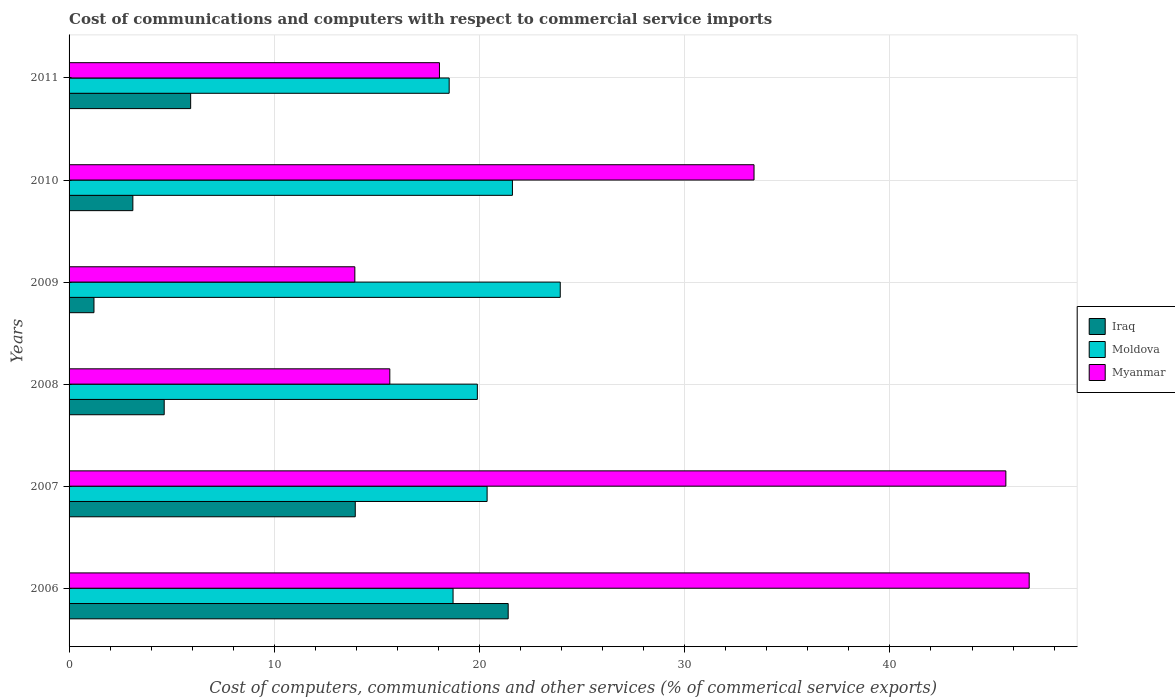Are the number of bars per tick equal to the number of legend labels?
Ensure brevity in your answer.  Yes. Are the number of bars on each tick of the Y-axis equal?
Make the answer very short. Yes. What is the label of the 2nd group of bars from the top?
Offer a very short reply. 2010. What is the cost of communications and computers in Moldova in 2008?
Ensure brevity in your answer.  19.9. Across all years, what is the maximum cost of communications and computers in Moldova?
Ensure brevity in your answer.  23.94. Across all years, what is the minimum cost of communications and computers in Iraq?
Ensure brevity in your answer.  1.21. In which year was the cost of communications and computers in Myanmar maximum?
Your answer should be compact. 2006. What is the total cost of communications and computers in Iraq in the graph?
Give a very brief answer. 50.23. What is the difference between the cost of communications and computers in Moldova in 2006 and that in 2009?
Keep it short and to the point. -5.22. What is the difference between the cost of communications and computers in Iraq in 2010 and the cost of communications and computers in Moldova in 2008?
Provide a succinct answer. -16.79. What is the average cost of communications and computers in Iraq per year?
Make the answer very short. 8.37. In the year 2007, what is the difference between the cost of communications and computers in Myanmar and cost of communications and computers in Moldova?
Ensure brevity in your answer.  25.28. In how many years, is the cost of communications and computers in Iraq greater than 14 %?
Offer a terse response. 1. What is the ratio of the cost of communications and computers in Myanmar in 2010 to that in 2011?
Ensure brevity in your answer.  1.85. Is the difference between the cost of communications and computers in Myanmar in 2010 and 2011 greater than the difference between the cost of communications and computers in Moldova in 2010 and 2011?
Provide a succinct answer. Yes. What is the difference between the highest and the second highest cost of communications and computers in Myanmar?
Your answer should be compact. 1.14. What is the difference between the highest and the lowest cost of communications and computers in Iraq?
Provide a short and direct response. 20.19. What does the 2nd bar from the top in 2010 represents?
Provide a short and direct response. Moldova. What does the 3rd bar from the bottom in 2010 represents?
Your answer should be compact. Myanmar. How many bars are there?
Make the answer very short. 18. Are all the bars in the graph horizontal?
Provide a succinct answer. Yes. How many years are there in the graph?
Provide a succinct answer. 6. What is the difference between two consecutive major ticks on the X-axis?
Your response must be concise. 10. Are the values on the major ticks of X-axis written in scientific E-notation?
Your response must be concise. No. Does the graph contain grids?
Give a very brief answer. Yes. How many legend labels are there?
Provide a succinct answer. 3. What is the title of the graph?
Your answer should be compact. Cost of communications and computers with respect to commercial service imports. What is the label or title of the X-axis?
Provide a short and direct response. Cost of computers, communications and other services (% of commerical service exports). What is the Cost of computers, communications and other services (% of commerical service exports) in Iraq in 2006?
Provide a short and direct response. 21.4. What is the Cost of computers, communications and other services (% of commerical service exports) of Moldova in 2006?
Make the answer very short. 18.71. What is the Cost of computers, communications and other services (% of commerical service exports) in Myanmar in 2006?
Provide a succinct answer. 46.79. What is the Cost of computers, communications and other services (% of commerical service exports) of Iraq in 2007?
Provide a short and direct response. 13.95. What is the Cost of computers, communications and other services (% of commerical service exports) in Moldova in 2007?
Provide a short and direct response. 20.37. What is the Cost of computers, communications and other services (% of commerical service exports) in Myanmar in 2007?
Give a very brief answer. 45.65. What is the Cost of computers, communications and other services (% of commerical service exports) in Iraq in 2008?
Offer a terse response. 4.64. What is the Cost of computers, communications and other services (% of commerical service exports) in Moldova in 2008?
Keep it short and to the point. 19.9. What is the Cost of computers, communications and other services (% of commerical service exports) of Myanmar in 2008?
Provide a succinct answer. 15.63. What is the Cost of computers, communications and other services (% of commerical service exports) of Iraq in 2009?
Ensure brevity in your answer.  1.21. What is the Cost of computers, communications and other services (% of commerical service exports) of Moldova in 2009?
Your response must be concise. 23.94. What is the Cost of computers, communications and other services (% of commerical service exports) in Myanmar in 2009?
Keep it short and to the point. 13.93. What is the Cost of computers, communications and other services (% of commerical service exports) of Iraq in 2010?
Ensure brevity in your answer.  3.11. What is the Cost of computers, communications and other services (% of commerical service exports) of Moldova in 2010?
Provide a succinct answer. 21.6. What is the Cost of computers, communications and other services (% of commerical service exports) in Myanmar in 2010?
Offer a very short reply. 33.38. What is the Cost of computers, communications and other services (% of commerical service exports) in Iraq in 2011?
Your response must be concise. 5.92. What is the Cost of computers, communications and other services (% of commerical service exports) in Moldova in 2011?
Give a very brief answer. 18.52. What is the Cost of computers, communications and other services (% of commerical service exports) in Myanmar in 2011?
Make the answer very short. 18.05. Across all years, what is the maximum Cost of computers, communications and other services (% of commerical service exports) in Iraq?
Your response must be concise. 21.4. Across all years, what is the maximum Cost of computers, communications and other services (% of commerical service exports) in Moldova?
Your answer should be very brief. 23.94. Across all years, what is the maximum Cost of computers, communications and other services (% of commerical service exports) in Myanmar?
Your answer should be very brief. 46.79. Across all years, what is the minimum Cost of computers, communications and other services (% of commerical service exports) in Iraq?
Your answer should be compact. 1.21. Across all years, what is the minimum Cost of computers, communications and other services (% of commerical service exports) in Moldova?
Keep it short and to the point. 18.52. Across all years, what is the minimum Cost of computers, communications and other services (% of commerical service exports) of Myanmar?
Your response must be concise. 13.93. What is the total Cost of computers, communications and other services (% of commerical service exports) of Iraq in the graph?
Keep it short and to the point. 50.23. What is the total Cost of computers, communications and other services (% of commerical service exports) in Moldova in the graph?
Provide a succinct answer. 123.04. What is the total Cost of computers, communications and other services (% of commerical service exports) of Myanmar in the graph?
Make the answer very short. 173.42. What is the difference between the Cost of computers, communications and other services (% of commerical service exports) in Iraq in 2006 and that in 2007?
Ensure brevity in your answer.  7.45. What is the difference between the Cost of computers, communications and other services (% of commerical service exports) in Moldova in 2006 and that in 2007?
Offer a terse response. -1.66. What is the difference between the Cost of computers, communications and other services (% of commerical service exports) in Myanmar in 2006 and that in 2007?
Make the answer very short. 1.14. What is the difference between the Cost of computers, communications and other services (% of commerical service exports) of Iraq in 2006 and that in 2008?
Provide a short and direct response. 16.76. What is the difference between the Cost of computers, communications and other services (% of commerical service exports) of Moldova in 2006 and that in 2008?
Offer a terse response. -1.18. What is the difference between the Cost of computers, communications and other services (% of commerical service exports) of Myanmar in 2006 and that in 2008?
Your response must be concise. 31.16. What is the difference between the Cost of computers, communications and other services (% of commerical service exports) of Iraq in 2006 and that in 2009?
Offer a terse response. 20.19. What is the difference between the Cost of computers, communications and other services (% of commerical service exports) in Moldova in 2006 and that in 2009?
Make the answer very short. -5.22. What is the difference between the Cost of computers, communications and other services (% of commerical service exports) in Myanmar in 2006 and that in 2009?
Your answer should be compact. 32.86. What is the difference between the Cost of computers, communications and other services (% of commerical service exports) of Iraq in 2006 and that in 2010?
Make the answer very short. 18.29. What is the difference between the Cost of computers, communications and other services (% of commerical service exports) of Moldova in 2006 and that in 2010?
Ensure brevity in your answer.  -2.89. What is the difference between the Cost of computers, communications and other services (% of commerical service exports) in Myanmar in 2006 and that in 2010?
Keep it short and to the point. 13.41. What is the difference between the Cost of computers, communications and other services (% of commerical service exports) of Iraq in 2006 and that in 2011?
Offer a terse response. 15.47. What is the difference between the Cost of computers, communications and other services (% of commerical service exports) of Moldova in 2006 and that in 2011?
Make the answer very short. 0.19. What is the difference between the Cost of computers, communications and other services (% of commerical service exports) of Myanmar in 2006 and that in 2011?
Ensure brevity in your answer.  28.74. What is the difference between the Cost of computers, communications and other services (% of commerical service exports) in Iraq in 2007 and that in 2008?
Ensure brevity in your answer.  9.31. What is the difference between the Cost of computers, communications and other services (% of commerical service exports) of Moldova in 2007 and that in 2008?
Keep it short and to the point. 0.48. What is the difference between the Cost of computers, communications and other services (% of commerical service exports) in Myanmar in 2007 and that in 2008?
Give a very brief answer. 30.02. What is the difference between the Cost of computers, communications and other services (% of commerical service exports) of Iraq in 2007 and that in 2009?
Ensure brevity in your answer.  12.73. What is the difference between the Cost of computers, communications and other services (% of commerical service exports) of Moldova in 2007 and that in 2009?
Offer a terse response. -3.56. What is the difference between the Cost of computers, communications and other services (% of commerical service exports) of Myanmar in 2007 and that in 2009?
Offer a terse response. 31.72. What is the difference between the Cost of computers, communications and other services (% of commerical service exports) in Iraq in 2007 and that in 2010?
Your answer should be compact. 10.84. What is the difference between the Cost of computers, communications and other services (% of commerical service exports) in Moldova in 2007 and that in 2010?
Ensure brevity in your answer.  -1.23. What is the difference between the Cost of computers, communications and other services (% of commerical service exports) in Myanmar in 2007 and that in 2010?
Make the answer very short. 12.27. What is the difference between the Cost of computers, communications and other services (% of commerical service exports) in Iraq in 2007 and that in 2011?
Keep it short and to the point. 8.02. What is the difference between the Cost of computers, communications and other services (% of commerical service exports) of Moldova in 2007 and that in 2011?
Your answer should be very brief. 1.85. What is the difference between the Cost of computers, communications and other services (% of commerical service exports) of Myanmar in 2007 and that in 2011?
Your response must be concise. 27.6. What is the difference between the Cost of computers, communications and other services (% of commerical service exports) in Iraq in 2008 and that in 2009?
Your answer should be compact. 3.42. What is the difference between the Cost of computers, communications and other services (% of commerical service exports) of Moldova in 2008 and that in 2009?
Your answer should be very brief. -4.04. What is the difference between the Cost of computers, communications and other services (% of commerical service exports) of Myanmar in 2008 and that in 2009?
Offer a terse response. 1.7. What is the difference between the Cost of computers, communications and other services (% of commerical service exports) of Iraq in 2008 and that in 2010?
Provide a succinct answer. 1.53. What is the difference between the Cost of computers, communications and other services (% of commerical service exports) of Moldova in 2008 and that in 2010?
Make the answer very short. -1.71. What is the difference between the Cost of computers, communications and other services (% of commerical service exports) in Myanmar in 2008 and that in 2010?
Ensure brevity in your answer.  -17.75. What is the difference between the Cost of computers, communications and other services (% of commerical service exports) in Iraq in 2008 and that in 2011?
Your response must be concise. -1.29. What is the difference between the Cost of computers, communications and other services (% of commerical service exports) of Moldova in 2008 and that in 2011?
Give a very brief answer. 1.37. What is the difference between the Cost of computers, communications and other services (% of commerical service exports) of Myanmar in 2008 and that in 2011?
Provide a short and direct response. -2.42. What is the difference between the Cost of computers, communications and other services (% of commerical service exports) of Iraq in 2009 and that in 2010?
Keep it short and to the point. -1.9. What is the difference between the Cost of computers, communications and other services (% of commerical service exports) in Moldova in 2009 and that in 2010?
Ensure brevity in your answer.  2.33. What is the difference between the Cost of computers, communications and other services (% of commerical service exports) of Myanmar in 2009 and that in 2010?
Your answer should be very brief. -19.45. What is the difference between the Cost of computers, communications and other services (% of commerical service exports) in Iraq in 2009 and that in 2011?
Your response must be concise. -4.71. What is the difference between the Cost of computers, communications and other services (% of commerical service exports) in Moldova in 2009 and that in 2011?
Your response must be concise. 5.41. What is the difference between the Cost of computers, communications and other services (% of commerical service exports) in Myanmar in 2009 and that in 2011?
Offer a very short reply. -4.12. What is the difference between the Cost of computers, communications and other services (% of commerical service exports) in Iraq in 2010 and that in 2011?
Keep it short and to the point. -2.82. What is the difference between the Cost of computers, communications and other services (% of commerical service exports) in Moldova in 2010 and that in 2011?
Your answer should be very brief. 3.08. What is the difference between the Cost of computers, communications and other services (% of commerical service exports) in Myanmar in 2010 and that in 2011?
Ensure brevity in your answer.  15.33. What is the difference between the Cost of computers, communications and other services (% of commerical service exports) in Iraq in 2006 and the Cost of computers, communications and other services (% of commerical service exports) in Moldova in 2007?
Provide a succinct answer. 1.03. What is the difference between the Cost of computers, communications and other services (% of commerical service exports) in Iraq in 2006 and the Cost of computers, communications and other services (% of commerical service exports) in Myanmar in 2007?
Make the answer very short. -24.25. What is the difference between the Cost of computers, communications and other services (% of commerical service exports) of Moldova in 2006 and the Cost of computers, communications and other services (% of commerical service exports) of Myanmar in 2007?
Ensure brevity in your answer.  -26.94. What is the difference between the Cost of computers, communications and other services (% of commerical service exports) in Iraq in 2006 and the Cost of computers, communications and other services (% of commerical service exports) in Moldova in 2008?
Your answer should be very brief. 1.5. What is the difference between the Cost of computers, communications and other services (% of commerical service exports) in Iraq in 2006 and the Cost of computers, communications and other services (% of commerical service exports) in Myanmar in 2008?
Make the answer very short. 5.77. What is the difference between the Cost of computers, communications and other services (% of commerical service exports) in Moldova in 2006 and the Cost of computers, communications and other services (% of commerical service exports) in Myanmar in 2008?
Offer a terse response. 3.08. What is the difference between the Cost of computers, communications and other services (% of commerical service exports) in Iraq in 2006 and the Cost of computers, communications and other services (% of commerical service exports) in Moldova in 2009?
Your answer should be compact. -2.54. What is the difference between the Cost of computers, communications and other services (% of commerical service exports) in Iraq in 2006 and the Cost of computers, communications and other services (% of commerical service exports) in Myanmar in 2009?
Provide a succinct answer. 7.47. What is the difference between the Cost of computers, communications and other services (% of commerical service exports) of Moldova in 2006 and the Cost of computers, communications and other services (% of commerical service exports) of Myanmar in 2009?
Provide a succinct answer. 4.79. What is the difference between the Cost of computers, communications and other services (% of commerical service exports) of Iraq in 2006 and the Cost of computers, communications and other services (% of commerical service exports) of Moldova in 2010?
Your response must be concise. -0.21. What is the difference between the Cost of computers, communications and other services (% of commerical service exports) in Iraq in 2006 and the Cost of computers, communications and other services (% of commerical service exports) in Myanmar in 2010?
Your answer should be compact. -11.98. What is the difference between the Cost of computers, communications and other services (% of commerical service exports) in Moldova in 2006 and the Cost of computers, communications and other services (% of commerical service exports) in Myanmar in 2010?
Offer a terse response. -14.67. What is the difference between the Cost of computers, communications and other services (% of commerical service exports) of Iraq in 2006 and the Cost of computers, communications and other services (% of commerical service exports) of Moldova in 2011?
Provide a succinct answer. 2.88. What is the difference between the Cost of computers, communications and other services (% of commerical service exports) of Iraq in 2006 and the Cost of computers, communications and other services (% of commerical service exports) of Myanmar in 2011?
Provide a succinct answer. 3.35. What is the difference between the Cost of computers, communications and other services (% of commerical service exports) in Moldova in 2006 and the Cost of computers, communications and other services (% of commerical service exports) in Myanmar in 2011?
Your answer should be compact. 0.66. What is the difference between the Cost of computers, communications and other services (% of commerical service exports) of Iraq in 2007 and the Cost of computers, communications and other services (% of commerical service exports) of Moldova in 2008?
Your response must be concise. -5.95. What is the difference between the Cost of computers, communications and other services (% of commerical service exports) in Iraq in 2007 and the Cost of computers, communications and other services (% of commerical service exports) in Myanmar in 2008?
Your answer should be very brief. -1.68. What is the difference between the Cost of computers, communications and other services (% of commerical service exports) of Moldova in 2007 and the Cost of computers, communications and other services (% of commerical service exports) of Myanmar in 2008?
Your answer should be compact. 4.74. What is the difference between the Cost of computers, communications and other services (% of commerical service exports) of Iraq in 2007 and the Cost of computers, communications and other services (% of commerical service exports) of Moldova in 2009?
Ensure brevity in your answer.  -9.99. What is the difference between the Cost of computers, communications and other services (% of commerical service exports) in Iraq in 2007 and the Cost of computers, communications and other services (% of commerical service exports) in Myanmar in 2009?
Give a very brief answer. 0.02. What is the difference between the Cost of computers, communications and other services (% of commerical service exports) in Moldova in 2007 and the Cost of computers, communications and other services (% of commerical service exports) in Myanmar in 2009?
Make the answer very short. 6.45. What is the difference between the Cost of computers, communications and other services (% of commerical service exports) in Iraq in 2007 and the Cost of computers, communications and other services (% of commerical service exports) in Moldova in 2010?
Keep it short and to the point. -7.66. What is the difference between the Cost of computers, communications and other services (% of commerical service exports) in Iraq in 2007 and the Cost of computers, communications and other services (% of commerical service exports) in Myanmar in 2010?
Offer a very short reply. -19.43. What is the difference between the Cost of computers, communications and other services (% of commerical service exports) in Moldova in 2007 and the Cost of computers, communications and other services (% of commerical service exports) in Myanmar in 2010?
Offer a very short reply. -13.01. What is the difference between the Cost of computers, communications and other services (% of commerical service exports) in Iraq in 2007 and the Cost of computers, communications and other services (% of commerical service exports) in Moldova in 2011?
Keep it short and to the point. -4.58. What is the difference between the Cost of computers, communications and other services (% of commerical service exports) in Iraq in 2007 and the Cost of computers, communications and other services (% of commerical service exports) in Myanmar in 2011?
Your answer should be very brief. -4.1. What is the difference between the Cost of computers, communications and other services (% of commerical service exports) of Moldova in 2007 and the Cost of computers, communications and other services (% of commerical service exports) of Myanmar in 2011?
Provide a short and direct response. 2.32. What is the difference between the Cost of computers, communications and other services (% of commerical service exports) of Iraq in 2008 and the Cost of computers, communications and other services (% of commerical service exports) of Moldova in 2009?
Your answer should be compact. -19.3. What is the difference between the Cost of computers, communications and other services (% of commerical service exports) in Iraq in 2008 and the Cost of computers, communications and other services (% of commerical service exports) in Myanmar in 2009?
Keep it short and to the point. -9.29. What is the difference between the Cost of computers, communications and other services (% of commerical service exports) of Moldova in 2008 and the Cost of computers, communications and other services (% of commerical service exports) of Myanmar in 2009?
Your response must be concise. 5.97. What is the difference between the Cost of computers, communications and other services (% of commerical service exports) of Iraq in 2008 and the Cost of computers, communications and other services (% of commerical service exports) of Moldova in 2010?
Make the answer very short. -16.97. What is the difference between the Cost of computers, communications and other services (% of commerical service exports) in Iraq in 2008 and the Cost of computers, communications and other services (% of commerical service exports) in Myanmar in 2010?
Your answer should be compact. -28.74. What is the difference between the Cost of computers, communications and other services (% of commerical service exports) in Moldova in 2008 and the Cost of computers, communications and other services (% of commerical service exports) in Myanmar in 2010?
Your answer should be very brief. -13.48. What is the difference between the Cost of computers, communications and other services (% of commerical service exports) of Iraq in 2008 and the Cost of computers, communications and other services (% of commerical service exports) of Moldova in 2011?
Your answer should be very brief. -13.89. What is the difference between the Cost of computers, communications and other services (% of commerical service exports) of Iraq in 2008 and the Cost of computers, communications and other services (% of commerical service exports) of Myanmar in 2011?
Your answer should be very brief. -13.41. What is the difference between the Cost of computers, communications and other services (% of commerical service exports) of Moldova in 2008 and the Cost of computers, communications and other services (% of commerical service exports) of Myanmar in 2011?
Your answer should be compact. 1.85. What is the difference between the Cost of computers, communications and other services (% of commerical service exports) of Iraq in 2009 and the Cost of computers, communications and other services (% of commerical service exports) of Moldova in 2010?
Your answer should be compact. -20.39. What is the difference between the Cost of computers, communications and other services (% of commerical service exports) of Iraq in 2009 and the Cost of computers, communications and other services (% of commerical service exports) of Myanmar in 2010?
Offer a terse response. -32.16. What is the difference between the Cost of computers, communications and other services (% of commerical service exports) in Moldova in 2009 and the Cost of computers, communications and other services (% of commerical service exports) in Myanmar in 2010?
Ensure brevity in your answer.  -9.44. What is the difference between the Cost of computers, communications and other services (% of commerical service exports) of Iraq in 2009 and the Cost of computers, communications and other services (% of commerical service exports) of Moldova in 2011?
Make the answer very short. -17.31. What is the difference between the Cost of computers, communications and other services (% of commerical service exports) in Iraq in 2009 and the Cost of computers, communications and other services (% of commerical service exports) in Myanmar in 2011?
Ensure brevity in your answer.  -16.84. What is the difference between the Cost of computers, communications and other services (% of commerical service exports) of Moldova in 2009 and the Cost of computers, communications and other services (% of commerical service exports) of Myanmar in 2011?
Offer a very short reply. 5.89. What is the difference between the Cost of computers, communications and other services (% of commerical service exports) of Iraq in 2010 and the Cost of computers, communications and other services (% of commerical service exports) of Moldova in 2011?
Your response must be concise. -15.41. What is the difference between the Cost of computers, communications and other services (% of commerical service exports) in Iraq in 2010 and the Cost of computers, communications and other services (% of commerical service exports) in Myanmar in 2011?
Your response must be concise. -14.94. What is the difference between the Cost of computers, communications and other services (% of commerical service exports) in Moldova in 2010 and the Cost of computers, communications and other services (% of commerical service exports) in Myanmar in 2011?
Offer a very short reply. 3.56. What is the average Cost of computers, communications and other services (% of commerical service exports) of Iraq per year?
Your answer should be very brief. 8.37. What is the average Cost of computers, communications and other services (% of commerical service exports) in Moldova per year?
Offer a terse response. 20.51. What is the average Cost of computers, communications and other services (% of commerical service exports) of Myanmar per year?
Your answer should be compact. 28.9. In the year 2006, what is the difference between the Cost of computers, communications and other services (% of commerical service exports) of Iraq and Cost of computers, communications and other services (% of commerical service exports) of Moldova?
Keep it short and to the point. 2.69. In the year 2006, what is the difference between the Cost of computers, communications and other services (% of commerical service exports) in Iraq and Cost of computers, communications and other services (% of commerical service exports) in Myanmar?
Your answer should be compact. -25.39. In the year 2006, what is the difference between the Cost of computers, communications and other services (% of commerical service exports) in Moldova and Cost of computers, communications and other services (% of commerical service exports) in Myanmar?
Offer a very short reply. -28.07. In the year 2007, what is the difference between the Cost of computers, communications and other services (% of commerical service exports) in Iraq and Cost of computers, communications and other services (% of commerical service exports) in Moldova?
Your response must be concise. -6.42. In the year 2007, what is the difference between the Cost of computers, communications and other services (% of commerical service exports) in Iraq and Cost of computers, communications and other services (% of commerical service exports) in Myanmar?
Provide a succinct answer. -31.7. In the year 2007, what is the difference between the Cost of computers, communications and other services (% of commerical service exports) of Moldova and Cost of computers, communications and other services (% of commerical service exports) of Myanmar?
Offer a very short reply. -25.28. In the year 2008, what is the difference between the Cost of computers, communications and other services (% of commerical service exports) of Iraq and Cost of computers, communications and other services (% of commerical service exports) of Moldova?
Provide a succinct answer. -15.26. In the year 2008, what is the difference between the Cost of computers, communications and other services (% of commerical service exports) of Iraq and Cost of computers, communications and other services (% of commerical service exports) of Myanmar?
Your answer should be very brief. -10.99. In the year 2008, what is the difference between the Cost of computers, communications and other services (% of commerical service exports) in Moldova and Cost of computers, communications and other services (% of commerical service exports) in Myanmar?
Provide a short and direct response. 4.27. In the year 2009, what is the difference between the Cost of computers, communications and other services (% of commerical service exports) of Iraq and Cost of computers, communications and other services (% of commerical service exports) of Moldova?
Offer a terse response. -22.72. In the year 2009, what is the difference between the Cost of computers, communications and other services (% of commerical service exports) of Iraq and Cost of computers, communications and other services (% of commerical service exports) of Myanmar?
Provide a succinct answer. -12.71. In the year 2009, what is the difference between the Cost of computers, communications and other services (% of commerical service exports) in Moldova and Cost of computers, communications and other services (% of commerical service exports) in Myanmar?
Ensure brevity in your answer.  10.01. In the year 2010, what is the difference between the Cost of computers, communications and other services (% of commerical service exports) of Iraq and Cost of computers, communications and other services (% of commerical service exports) of Moldova?
Offer a terse response. -18.5. In the year 2010, what is the difference between the Cost of computers, communications and other services (% of commerical service exports) of Iraq and Cost of computers, communications and other services (% of commerical service exports) of Myanmar?
Offer a very short reply. -30.27. In the year 2010, what is the difference between the Cost of computers, communications and other services (% of commerical service exports) of Moldova and Cost of computers, communications and other services (% of commerical service exports) of Myanmar?
Offer a terse response. -11.77. In the year 2011, what is the difference between the Cost of computers, communications and other services (% of commerical service exports) of Iraq and Cost of computers, communications and other services (% of commerical service exports) of Moldova?
Your response must be concise. -12.6. In the year 2011, what is the difference between the Cost of computers, communications and other services (% of commerical service exports) of Iraq and Cost of computers, communications and other services (% of commerical service exports) of Myanmar?
Ensure brevity in your answer.  -12.12. In the year 2011, what is the difference between the Cost of computers, communications and other services (% of commerical service exports) in Moldova and Cost of computers, communications and other services (% of commerical service exports) in Myanmar?
Provide a short and direct response. 0.47. What is the ratio of the Cost of computers, communications and other services (% of commerical service exports) of Iraq in 2006 to that in 2007?
Provide a short and direct response. 1.53. What is the ratio of the Cost of computers, communications and other services (% of commerical service exports) of Moldova in 2006 to that in 2007?
Give a very brief answer. 0.92. What is the ratio of the Cost of computers, communications and other services (% of commerical service exports) in Myanmar in 2006 to that in 2007?
Provide a succinct answer. 1.02. What is the ratio of the Cost of computers, communications and other services (% of commerical service exports) in Iraq in 2006 to that in 2008?
Your answer should be very brief. 4.62. What is the ratio of the Cost of computers, communications and other services (% of commerical service exports) in Moldova in 2006 to that in 2008?
Make the answer very short. 0.94. What is the ratio of the Cost of computers, communications and other services (% of commerical service exports) in Myanmar in 2006 to that in 2008?
Offer a terse response. 2.99. What is the ratio of the Cost of computers, communications and other services (% of commerical service exports) of Iraq in 2006 to that in 2009?
Your answer should be compact. 17.64. What is the ratio of the Cost of computers, communications and other services (% of commerical service exports) of Moldova in 2006 to that in 2009?
Your answer should be compact. 0.78. What is the ratio of the Cost of computers, communications and other services (% of commerical service exports) of Myanmar in 2006 to that in 2009?
Provide a short and direct response. 3.36. What is the ratio of the Cost of computers, communications and other services (% of commerical service exports) of Iraq in 2006 to that in 2010?
Offer a terse response. 6.88. What is the ratio of the Cost of computers, communications and other services (% of commerical service exports) in Moldova in 2006 to that in 2010?
Ensure brevity in your answer.  0.87. What is the ratio of the Cost of computers, communications and other services (% of commerical service exports) in Myanmar in 2006 to that in 2010?
Provide a short and direct response. 1.4. What is the ratio of the Cost of computers, communications and other services (% of commerical service exports) in Iraq in 2006 to that in 2011?
Offer a very short reply. 3.61. What is the ratio of the Cost of computers, communications and other services (% of commerical service exports) in Moldova in 2006 to that in 2011?
Provide a short and direct response. 1.01. What is the ratio of the Cost of computers, communications and other services (% of commerical service exports) of Myanmar in 2006 to that in 2011?
Offer a very short reply. 2.59. What is the ratio of the Cost of computers, communications and other services (% of commerical service exports) of Iraq in 2007 to that in 2008?
Provide a short and direct response. 3.01. What is the ratio of the Cost of computers, communications and other services (% of commerical service exports) in Moldova in 2007 to that in 2008?
Your response must be concise. 1.02. What is the ratio of the Cost of computers, communications and other services (% of commerical service exports) of Myanmar in 2007 to that in 2008?
Your answer should be compact. 2.92. What is the ratio of the Cost of computers, communications and other services (% of commerical service exports) in Iraq in 2007 to that in 2009?
Ensure brevity in your answer.  11.5. What is the ratio of the Cost of computers, communications and other services (% of commerical service exports) of Moldova in 2007 to that in 2009?
Offer a terse response. 0.85. What is the ratio of the Cost of computers, communications and other services (% of commerical service exports) of Myanmar in 2007 to that in 2009?
Make the answer very short. 3.28. What is the ratio of the Cost of computers, communications and other services (% of commerical service exports) in Iraq in 2007 to that in 2010?
Keep it short and to the point. 4.49. What is the ratio of the Cost of computers, communications and other services (% of commerical service exports) in Moldova in 2007 to that in 2010?
Give a very brief answer. 0.94. What is the ratio of the Cost of computers, communications and other services (% of commerical service exports) in Myanmar in 2007 to that in 2010?
Your answer should be very brief. 1.37. What is the ratio of the Cost of computers, communications and other services (% of commerical service exports) in Iraq in 2007 to that in 2011?
Give a very brief answer. 2.35. What is the ratio of the Cost of computers, communications and other services (% of commerical service exports) in Moldova in 2007 to that in 2011?
Your answer should be compact. 1.1. What is the ratio of the Cost of computers, communications and other services (% of commerical service exports) of Myanmar in 2007 to that in 2011?
Ensure brevity in your answer.  2.53. What is the ratio of the Cost of computers, communications and other services (% of commerical service exports) in Iraq in 2008 to that in 2009?
Your response must be concise. 3.82. What is the ratio of the Cost of computers, communications and other services (% of commerical service exports) of Moldova in 2008 to that in 2009?
Provide a succinct answer. 0.83. What is the ratio of the Cost of computers, communications and other services (% of commerical service exports) in Myanmar in 2008 to that in 2009?
Provide a succinct answer. 1.12. What is the ratio of the Cost of computers, communications and other services (% of commerical service exports) in Iraq in 2008 to that in 2010?
Make the answer very short. 1.49. What is the ratio of the Cost of computers, communications and other services (% of commerical service exports) in Moldova in 2008 to that in 2010?
Provide a succinct answer. 0.92. What is the ratio of the Cost of computers, communications and other services (% of commerical service exports) in Myanmar in 2008 to that in 2010?
Ensure brevity in your answer.  0.47. What is the ratio of the Cost of computers, communications and other services (% of commerical service exports) in Iraq in 2008 to that in 2011?
Offer a terse response. 0.78. What is the ratio of the Cost of computers, communications and other services (% of commerical service exports) in Moldova in 2008 to that in 2011?
Your response must be concise. 1.07. What is the ratio of the Cost of computers, communications and other services (% of commerical service exports) of Myanmar in 2008 to that in 2011?
Provide a succinct answer. 0.87. What is the ratio of the Cost of computers, communications and other services (% of commerical service exports) of Iraq in 2009 to that in 2010?
Offer a very short reply. 0.39. What is the ratio of the Cost of computers, communications and other services (% of commerical service exports) in Moldova in 2009 to that in 2010?
Offer a very short reply. 1.11. What is the ratio of the Cost of computers, communications and other services (% of commerical service exports) in Myanmar in 2009 to that in 2010?
Offer a very short reply. 0.42. What is the ratio of the Cost of computers, communications and other services (% of commerical service exports) in Iraq in 2009 to that in 2011?
Provide a succinct answer. 0.2. What is the ratio of the Cost of computers, communications and other services (% of commerical service exports) in Moldova in 2009 to that in 2011?
Offer a very short reply. 1.29. What is the ratio of the Cost of computers, communications and other services (% of commerical service exports) of Myanmar in 2009 to that in 2011?
Your response must be concise. 0.77. What is the ratio of the Cost of computers, communications and other services (% of commerical service exports) in Iraq in 2010 to that in 2011?
Give a very brief answer. 0.52. What is the ratio of the Cost of computers, communications and other services (% of commerical service exports) in Moldova in 2010 to that in 2011?
Give a very brief answer. 1.17. What is the ratio of the Cost of computers, communications and other services (% of commerical service exports) of Myanmar in 2010 to that in 2011?
Offer a terse response. 1.85. What is the difference between the highest and the second highest Cost of computers, communications and other services (% of commerical service exports) in Iraq?
Your answer should be compact. 7.45. What is the difference between the highest and the second highest Cost of computers, communications and other services (% of commerical service exports) in Moldova?
Provide a short and direct response. 2.33. What is the difference between the highest and the second highest Cost of computers, communications and other services (% of commerical service exports) in Myanmar?
Provide a short and direct response. 1.14. What is the difference between the highest and the lowest Cost of computers, communications and other services (% of commerical service exports) of Iraq?
Make the answer very short. 20.19. What is the difference between the highest and the lowest Cost of computers, communications and other services (% of commerical service exports) in Moldova?
Give a very brief answer. 5.41. What is the difference between the highest and the lowest Cost of computers, communications and other services (% of commerical service exports) in Myanmar?
Ensure brevity in your answer.  32.86. 